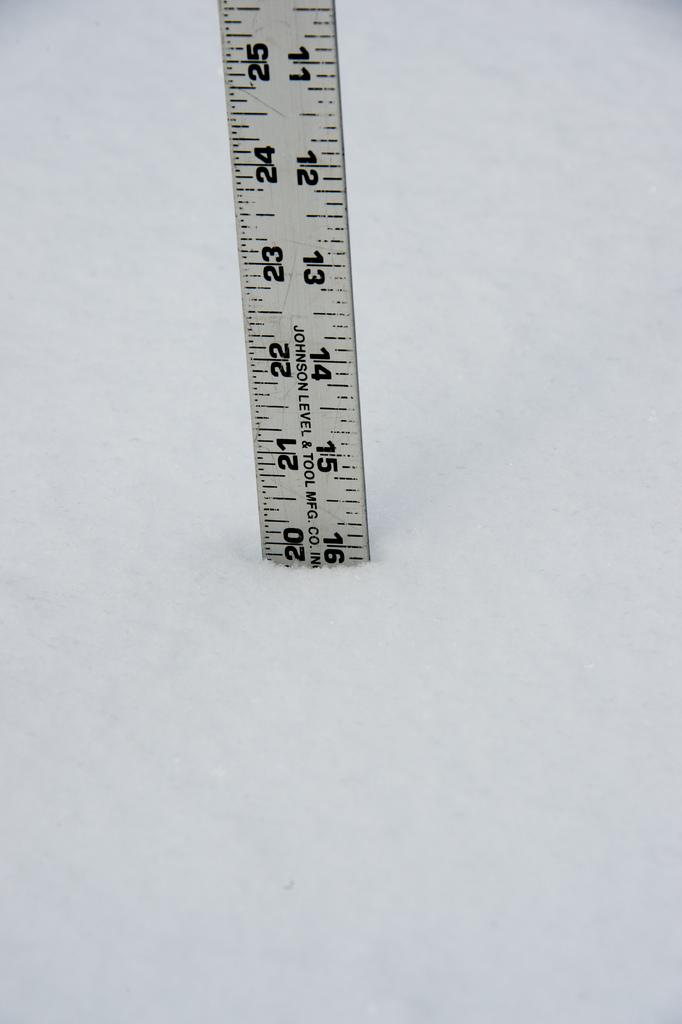What company name is on the tape measure?
Keep it short and to the point. Johnson level and tool. 